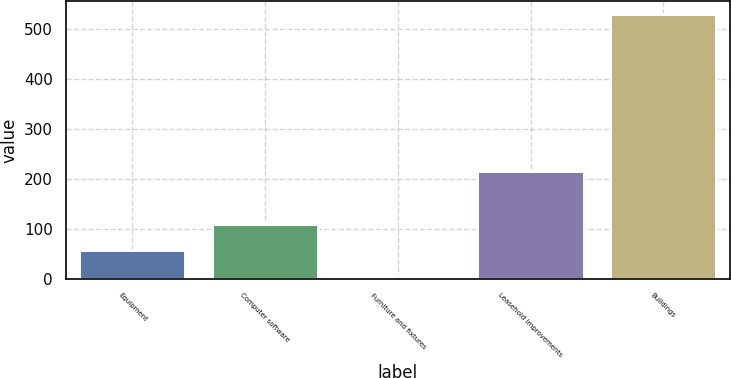<chart> <loc_0><loc_0><loc_500><loc_500><bar_chart><fcel>Equipment<fcel>Computer software<fcel>Furniture and fixtures<fcel>Leasehold improvements<fcel>Buildings<nl><fcel>57.5<fcel>110<fcel>5<fcel>216<fcel>530<nl></chart> 